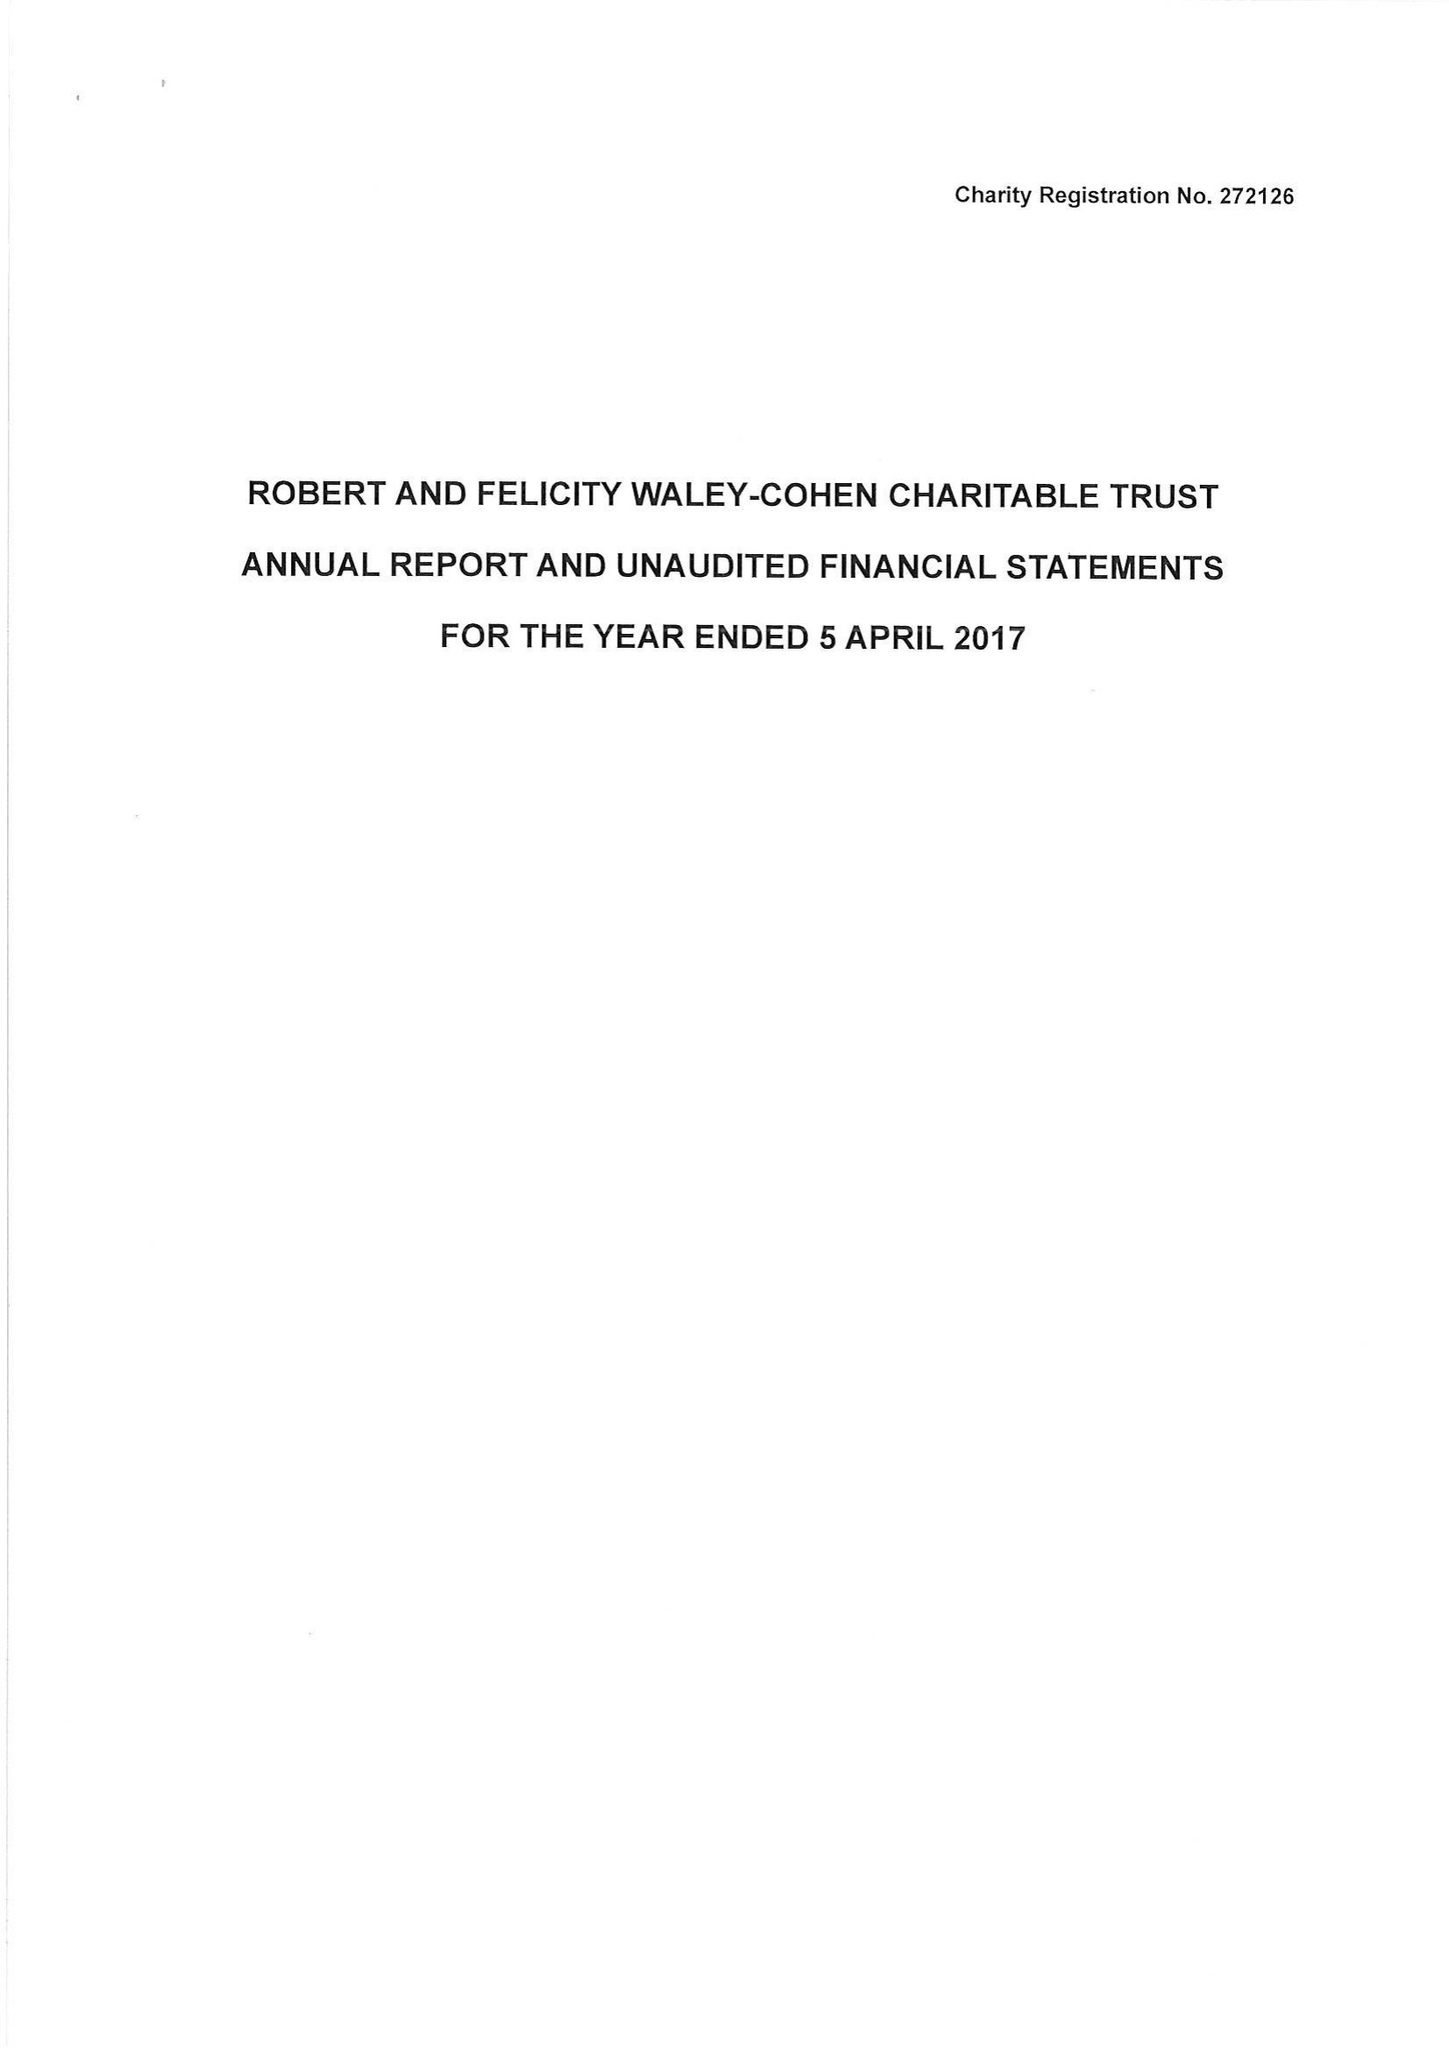What is the value for the report_date?
Answer the question using a single word or phrase. 2017-04-05 